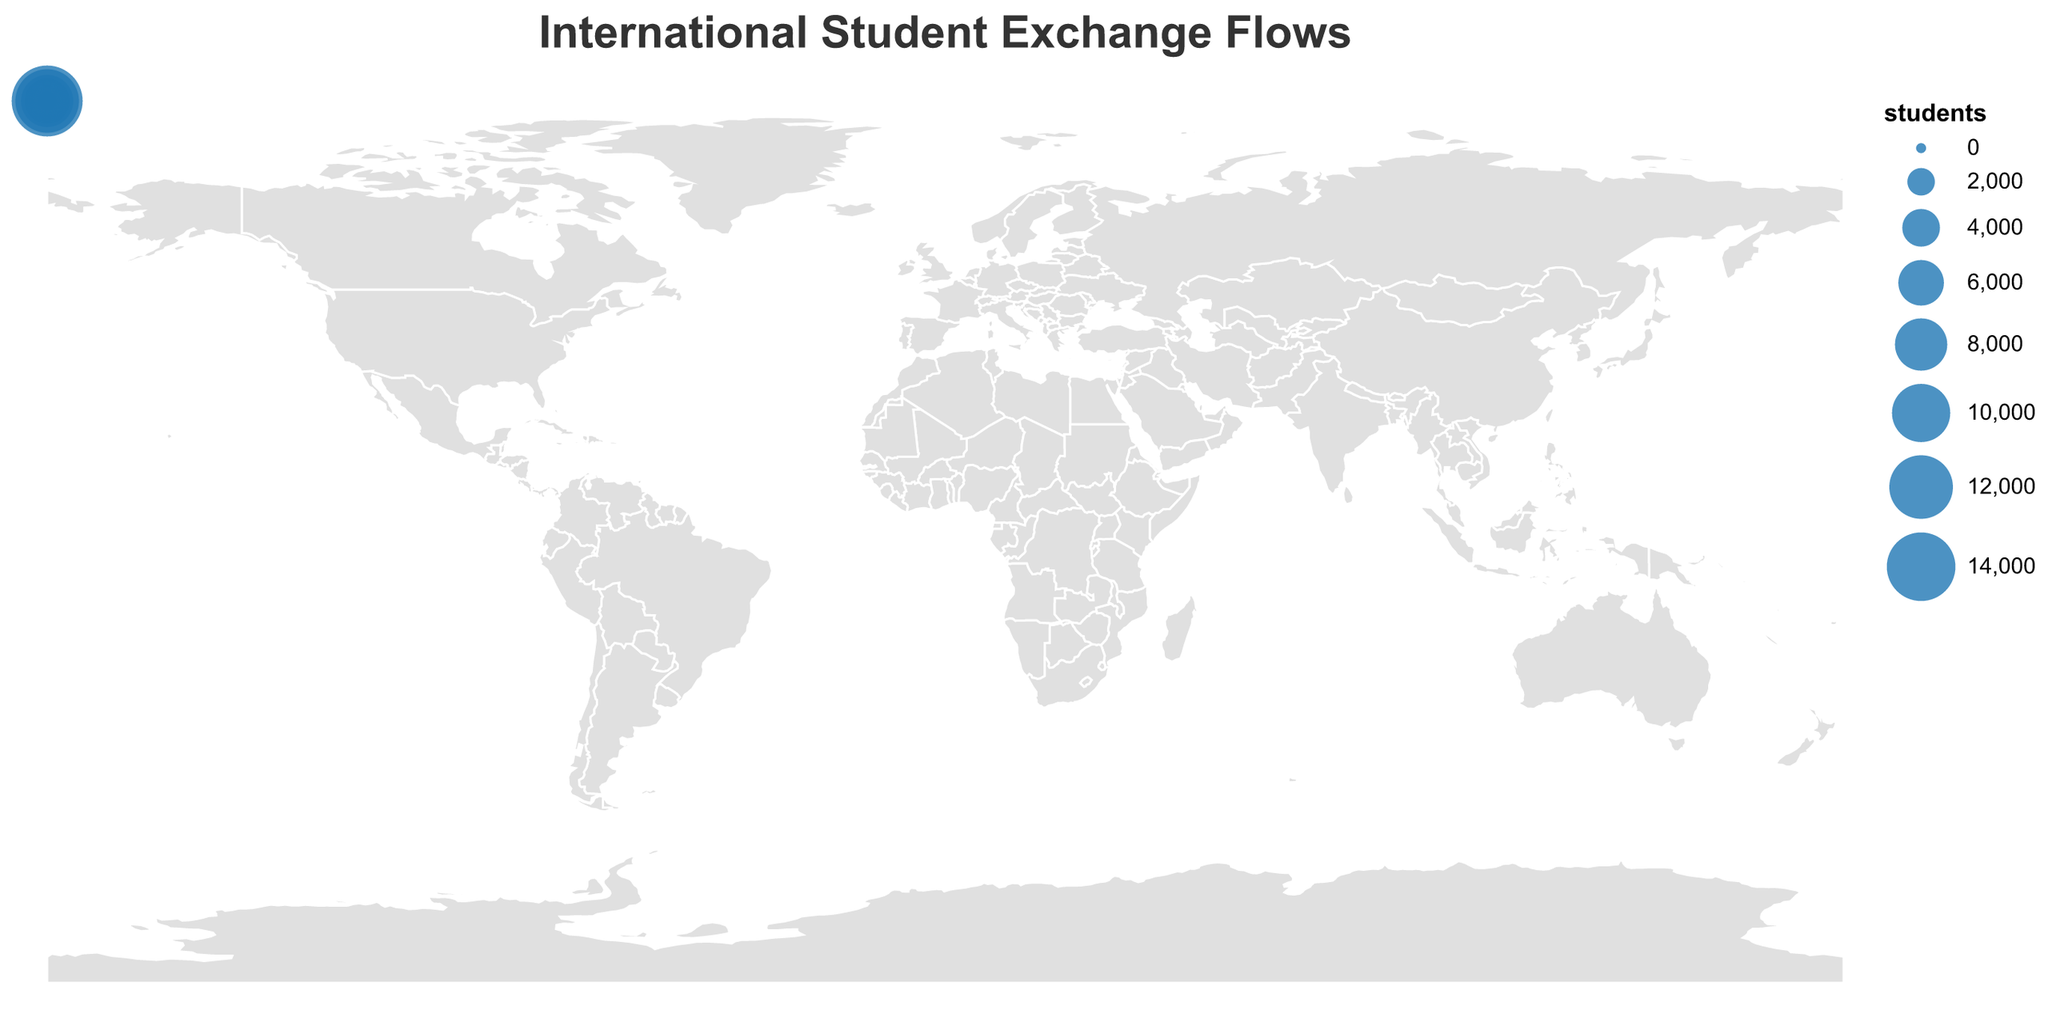How many student exchanges are represented in the figure? Count the total number of lines (rules) and circles representing student exchanges on the geographic plot. Each line and circle corresponds to an exchange route.
Answer: 20 Which origin country has the highest number of students sent to another country? Identify the country with the largest number value for students in the dataset. The thickest line or largest circle on the plot will indicate this.
Answer: United States Which pair of countries has the smallest student exchange flow? Look for the thinnest line or smallest circle, which signifies the lowest student number in the plotted data.
Answer: Austria to Hungary What is the total number of students exchanged between the United States and China (both directions)? Sum the student numbers for both directions represented by the United States to China and China to United States lines.
Answer: 27000 Which country has both the highest inflow and outflow of students? Compare the total student numbers for each country by summing their inflows and outflows and identify the country with the highest combined number.
Answer: United States On which continent do most outgoing student exchange routes originate? Visualize and count the number of origin points on each continent, then identify which continent has the most
Answer: Europe Which continent receives the fewest students from international exchanges? Count the number of destination points corresponding to each continent and identify the one with the least.
Answer: Africa What is the average number of students involved in exchanges originating from European countries? Sum the number of students sent from all European countries and divide by the number of European origin countries (only count countries located in Europe).  (Sum of students from the UK, France, Germany, Russia, Netherlands, Italy, Sweden, Ireland, Switzerland, Denmark, Belgium, Austria) / 12.
Answer: 3250 What is the largest student exchange route in the figure? Identify the route with the highest numerical value for students by examining the thickness of lines and size of circles.
Answer: United States to China Which two countries have a balanced student exchange, meaning the number of students sent and received are most similar? Compare each pair of countries in the dataset to find those whose number of students sent and received are closest to each other. E.g., United States and China have values of 15000 and 12000.
Answer: United States and China 